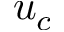<formula> <loc_0><loc_0><loc_500><loc_500>u _ { c }</formula> 